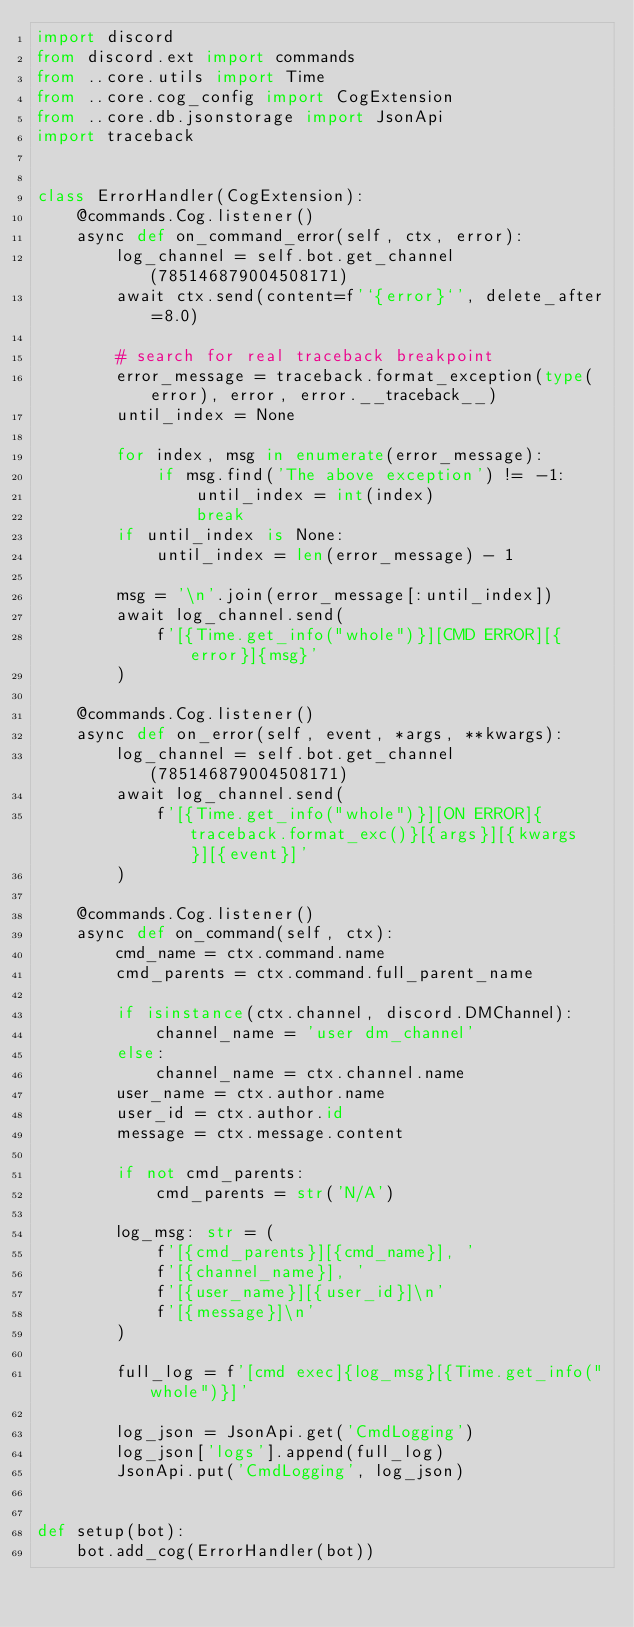<code> <loc_0><loc_0><loc_500><loc_500><_Python_>import discord
from discord.ext import commands
from ..core.utils import Time
from ..core.cog_config import CogExtension
from ..core.db.jsonstorage import JsonApi
import traceback


class ErrorHandler(CogExtension):
    @commands.Cog.listener()
    async def on_command_error(self, ctx, error):
        log_channel = self.bot.get_channel(785146879004508171)
        await ctx.send(content=f'`{error}`', delete_after=8.0)

        # search for real traceback breakpoint
        error_message = traceback.format_exception(type(error), error, error.__traceback__)
        until_index = None

        for index, msg in enumerate(error_message):
            if msg.find('The above exception') != -1:
                until_index = int(index)
                break
        if until_index is None:
            until_index = len(error_message) - 1

        msg = '\n'.join(error_message[:until_index])
        await log_channel.send(
            f'[{Time.get_info("whole")}][CMD ERROR][{error}]{msg}'
        )

    @commands.Cog.listener()
    async def on_error(self, event, *args, **kwargs):
        log_channel = self.bot.get_channel(785146879004508171)
        await log_channel.send(
            f'[{Time.get_info("whole")}][ON ERROR]{traceback.format_exc()}[{args}][{kwargs}][{event}]'
        )

    @commands.Cog.listener()
    async def on_command(self, ctx):
        cmd_name = ctx.command.name
        cmd_parents = ctx.command.full_parent_name

        if isinstance(ctx.channel, discord.DMChannel):
            channel_name = 'user dm_channel'
        else:
            channel_name = ctx.channel.name
        user_name = ctx.author.name
        user_id = ctx.author.id
        message = ctx.message.content

        if not cmd_parents:
            cmd_parents = str('N/A')

        log_msg: str = (
            f'[{cmd_parents}][{cmd_name}], '
            f'[{channel_name}], '
            f'[{user_name}][{user_id}]\n'
            f'[{message}]\n'
        )

        full_log = f'[cmd exec]{log_msg}[{Time.get_info("whole")}]'

        log_json = JsonApi.get('CmdLogging')
        log_json['logs'].append(full_log)
        JsonApi.put('CmdLogging', log_json)


def setup(bot):
    bot.add_cog(ErrorHandler(bot))
</code> 